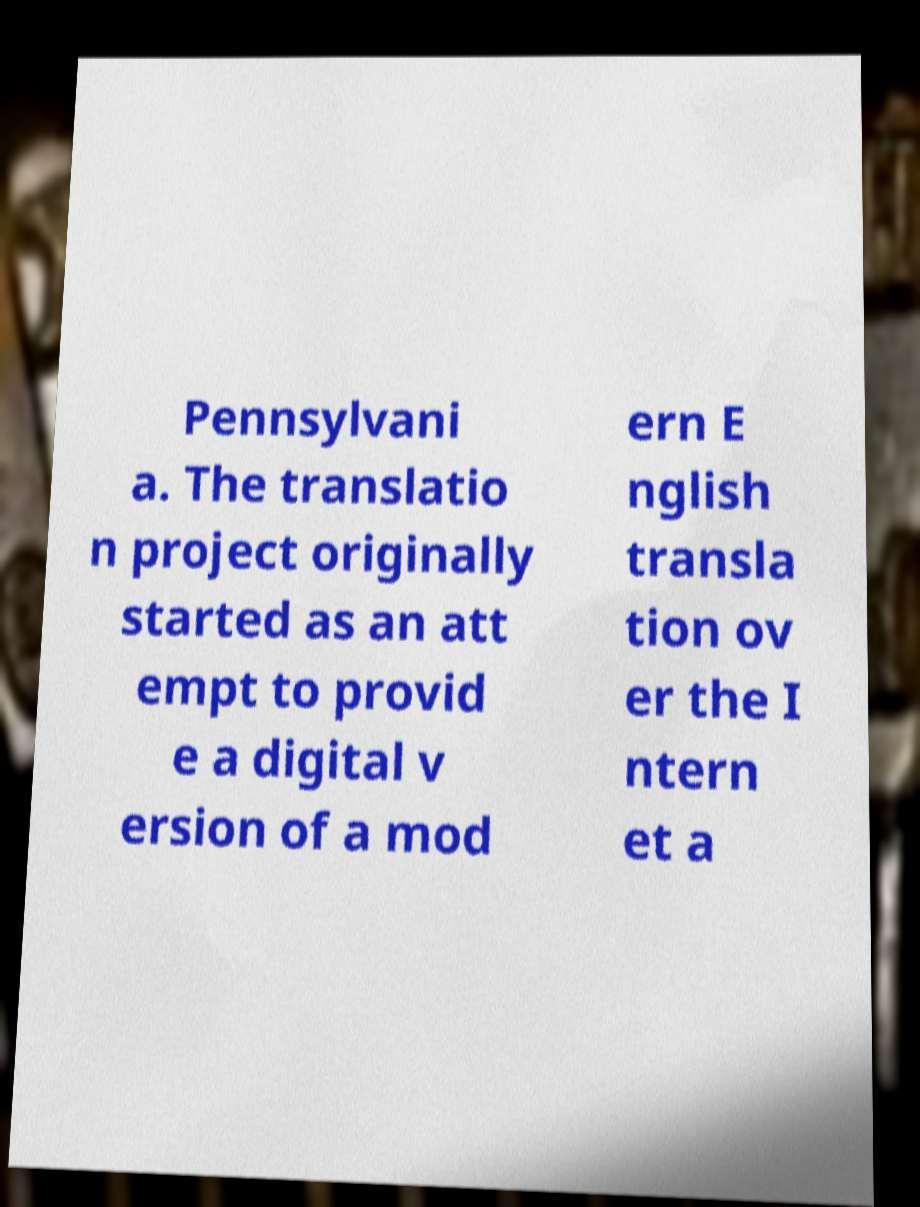Please read and relay the text visible in this image. What does it say? Pennsylvani a. The translatio n project originally started as an att empt to provid e a digital v ersion of a mod ern E nglish transla tion ov er the I ntern et a 